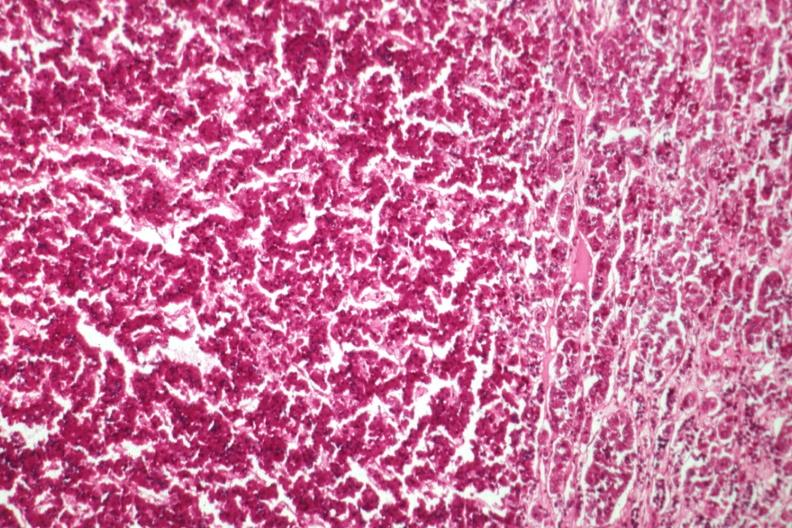what is present?
Answer the question using a single word or phrase. Endocrine 